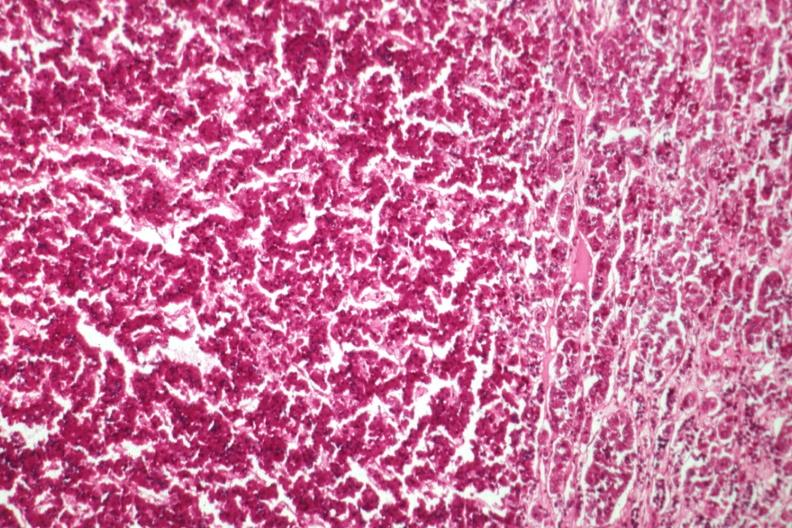what is present?
Answer the question using a single word or phrase. Endocrine 